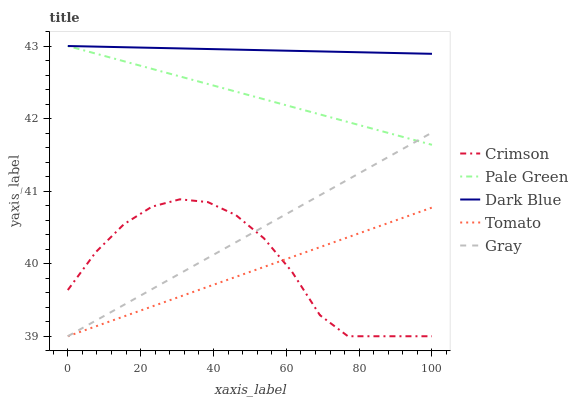Does Tomato have the minimum area under the curve?
Answer yes or no. Yes. Does Dark Blue have the maximum area under the curve?
Answer yes or no. Yes. Does Dark Blue have the minimum area under the curve?
Answer yes or no. No. Does Tomato have the maximum area under the curve?
Answer yes or no. No. Is Dark Blue the smoothest?
Answer yes or no. Yes. Is Crimson the roughest?
Answer yes or no. Yes. Is Tomato the smoothest?
Answer yes or no. No. Is Tomato the roughest?
Answer yes or no. No. Does Crimson have the lowest value?
Answer yes or no. Yes. Does Dark Blue have the lowest value?
Answer yes or no. No. Does Pale Green have the highest value?
Answer yes or no. Yes. Does Tomato have the highest value?
Answer yes or no. No. Is Tomato less than Pale Green?
Answer yes or no. Yes. Is Dark Blue greater than Tomato?
Answer yes or no. Yes. Does Pale Green intersect Dark Blue?
Answer yes or no. Yes. Is Pale Green less than Dark Blue?
Answer yes or no. No. Is Pale Green greater than Dark Blue?
Answer yes or no. No. Does Tomato intersect Pale Green?
Answer yes or no. No. 